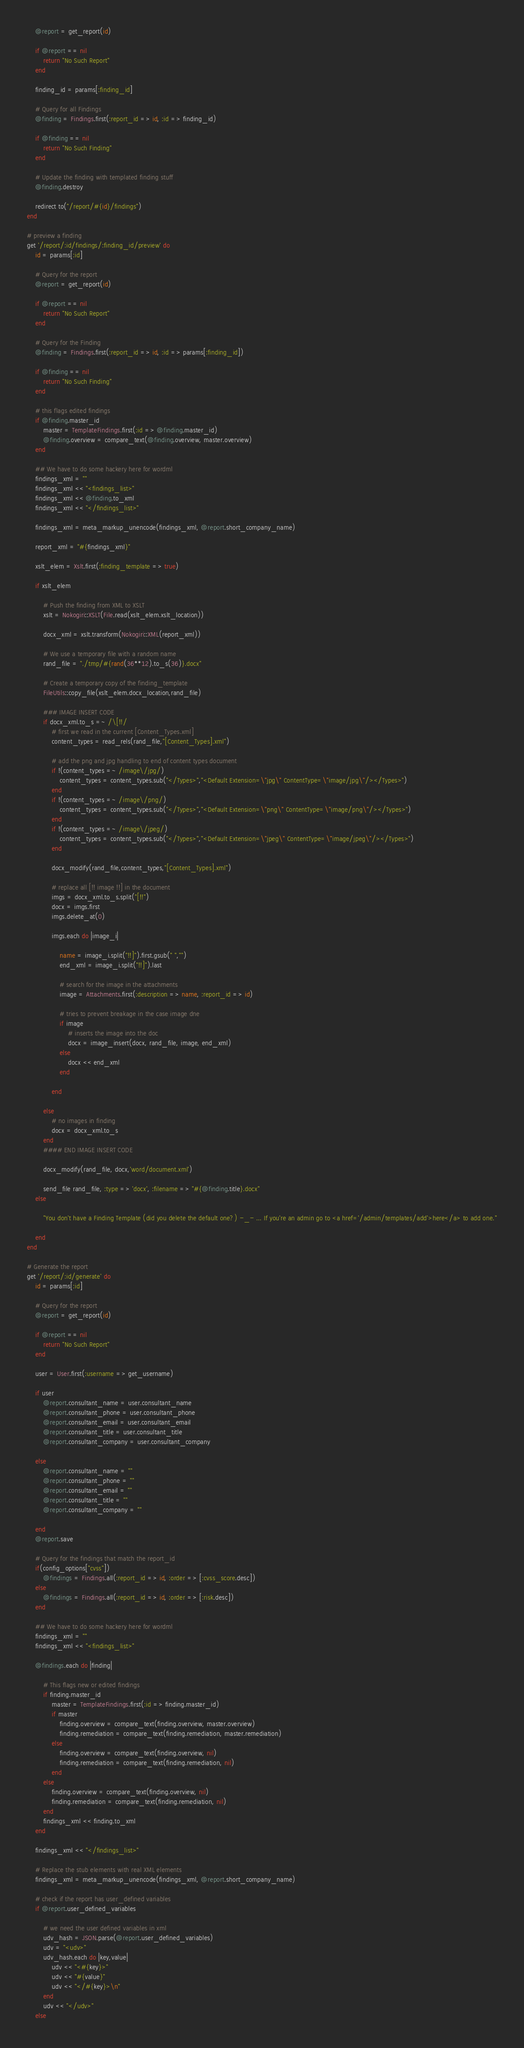<code> <loc_0><loc_0><loc_500><loc_500><_Ruby_>    @report = get_report(id)

    if @report == nil
        return "No Such Report"
    end

    finding_id = params[:finding_id]

    # Query for all Findings
    @finding = Findings.first(:report_id => id, :id => finding_id)

    if @finding == nil
        return "No Such Finding"
    end

    # Update the finding with templated finding stuff
    @finding.destroy

    redirect to("/report/#{id}/findings")
end

# preview a finding
get '/report/:id/findings/:finding_id/preview' do
    id = params[:id]

    # Query for the report
    @report = get_report(id)

    if @report == nil
        return "No Such Report"
    end

    # Query for the Finding
    @finding = Findings.first(:report_id => id, :id => params[:finding_id])

    if @finding == nil
        return "No Such Finding"
    end

    # this flags edited findings
    if @finding.master_id
        master = TemplateFindings.first(:id => @finding.master_id)
        @finding.overview = compare_text(@finding.overview, master.overview)
    end

    ## We have to do some hackery here for wordml
    findings_xml = ""
    findings_xml << "<findings_list>"
    findings_xml << @finding.to_xml
    findings_xml << "</findings_list>"

    findings_xml = meta_markup_unencode(findings_xml, @report.short_company_name)

    report_xml = "#{findings_xml}"

    xslt_elem = Xslt.first(:finding_template => true)

    if xslt_elem

        # Push the finding from XML to XSLT
        xslt = Nokogiri::XSLT(File.read(xslt_elem.xslt_location))

        docx_xml = xslt.transform(Nokogiri::XML(report_xml))

        # We use a temporary file with a random name
        rand_file = "./tmp/#{rand(36**12).to_s(36)}.docx"

        # Create a temporary copy of the finding_template
        FileUtils::copy_file(xslt_elem.docx_location,rand_file)

        ### IMAGE INSERT CODE
        if docx_xml.to_s =~ /\[!!/
            # first we read in the current [Content_Types.xml]
            content_types = read_rels(rand_file,"[Content_Types].xml")

            # add the png and jpg handling to end of content types document
            if !(content_types =~ /image\/jpg/)
                content_types = content_types.sub("</Types>","<Default Extension=\"jpg\" ContentType=\"image/jpg\"/></Types>")
            end
            if !(content_types =~ /image\/png/)
                content_types = content_types.sub("</Types>","<Default Extension=\"png\" ContentType=\"image/png\"/></Types>")
            end
            if !(content_types =~ /image\/jpeg/)
                content_types = content_types.sub("</Types>","<Default Extension=\"jpeg\" ContentType=\"image/jpeg\"/></Types>")
            end

            docx_modify(rand_file,content_types,"[Content_Types].xml")

            # replace all [!! image !!] in the document
            imgs = docx_xml.to_s.split("[!!")
            docx = imgs.first
            imgs.delete_at(0)

            imgs.each do |image_i|

                name = image_i.split("!!]").first.gsub(" ","")
                end_xml = image_i.split("!!]").last

                # search for the image in the attachments
                image = Attachments.first(:description => name, :report_id => id)

                # tries to prevent breakage in the case image dne
                if image
                    # inserts the image into the doc
                    docx = image_insert(docx, rand_file, image, end_xml)
                else
                    docx << end_xml
                end

            end

        else
            # no images in finding
            docx = docx_xml.to_s
        end
        #### END IMAGE INSERT CODE

        docx_modify(rand_file, docx,'word/document.xml')

        send_file rand_file, :type => 'docx', :filename => "#{@finding.title}.docx"
    else

        "You don't have a Finding Template (did you delete the default one?) -_- ... If you're an admin go to <a href='/admin/templates/add'>here</a> to add one."

    end
end

# Generate the report
get '/report/:id/generate' do
    id = params[:id]

    # Query for the report
    @report = get_report(id)

    if @report == nil
        return "No Such Report"
    end

    user = User.first(:username => get_username)

    if user
        @report.consultant_name = user.consultant_name
        @report.consultant_phone = user.consultant_phone
        @report.consultant_email = user.consultant_email
        @report.consultant_title = user.consultant_title
        @report.consultant_company = user.consultant_company

    else
        @report.consultant_name = ""
        @report.consultant_phone = ""
        @report.consultant_email = ""
        @report.consultant_title = ""
        @report.consultant_company = ""

    end
    @report.save

    # Query for the findings that match the report_id
    if(config_options["cvss"])
        @findings = Findings.all(:report_id => id, :order => [:cvss_score.desc])
    else
        @findings = Findings.all(:report_id => id, :order => [:risk.desc])
    end

    ## We have to do some hackery here for wordml
    findings_xml = ""
    findings_xml << "<findings_list>"

    @findings.each do |finding|

        # This flags new or edited findings
        if finding.master_id
            master = TemplateFindings.first(:id => finding.master_id)
            if master
                finding.overview = compare_text(finding.overview, master.overview)
                finding.remediation = compare_text(finding.remediation, master.remediation)
            else
                finding.overview = compare_text(finding.overview, nil)
                finding.remediation = compare_text(finding.remediation, nil)
            end
        else
            finding.overview = compare_text(finding.overview, nil)
            finding.remediation = compare_text(finding.remediation, nil)
        end
        findings_xml << finding.to_xml
    end

    findings_xml << "</findings_list>"

    # Replace the stub elements with real XML elements
    findings_xml = meta_markup_unencode(findings_xml, @report.short_company_name)

    # check if the report has user_defined variables
    if @report.user_defined_variables

        # we need the user defined variables in xml
        udv_hash = JSON.parse(@report.user_defined_variables)
        udv = "<udv>"
        udv_hash.each do |key,value|
            udv << "<#{key}>"
            udv << "#{value}"
            udv << "</#{key}>\n"
        end
        udv << "</udv>"
    else</code> 